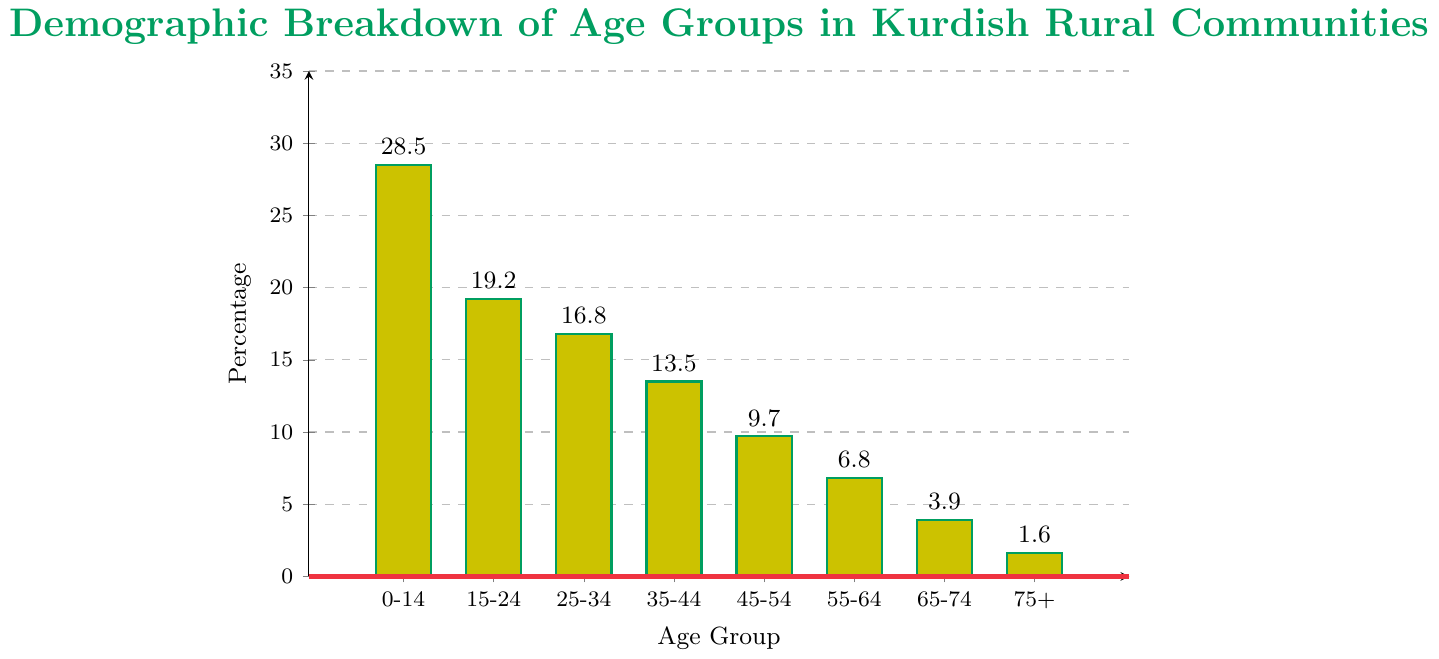Which age group has the highest percentage in Kurdish rural communities? The bar representing the age group 0-14 is the tallest, indicating the highest percentage.
Answer: 0-14 Which two age groups together form the lowest percentage? Add the percentages of the two smallest bars: 65-74 (3.9%) and 75+ (1.6%). The sum is 5.5%, which is the lowest combined percentage.
Answer: 65-74 and 75+ What is the total percentage of people aged 55 and above in Kurdish rural communities? Sum the percentages of the age groups 55-64, 65-74, and 75+: 6.8% + 3.9% + 1.6% = 12.3%.
Answer: 12.3% Which age group has a percentage greater than 15% but less than 20%? The bar representing the age group 15-24 has a value of 19.2%, which satisfies the condition of being between 15% and 20%.
Answer: 15-24 Compare the percentages of the age groups 25-34 and 45-54. Which is higher, and by how much? The percentage for 25-34 is 16.8%, and for 45-54, it is 9.7%. The difference is 16.8% - 9.7% = 7.1%.
Answer: 25-34 by 7.1% What is the sum of the percentages for age groups 0-14 and 35-44? Add the percentages for 0-14 (28.5%) and 35-44 (13.5%): 28.5% + 13.5% = 42%.
Answer: 42% Which age group's bar is colored with the same color scheme but appears the shortest visually? The bar for the 75+ age group appears the shortest visually on the chart.
Answer: 75+ Does any age group have a percentage exactly one-third of the highest percentage? The highest percentage is 28.5% (0-14). One-third of this is 28.5% / 3 = 9.5%. No age group's percentage is exactly 9.5%.
Answer: No 